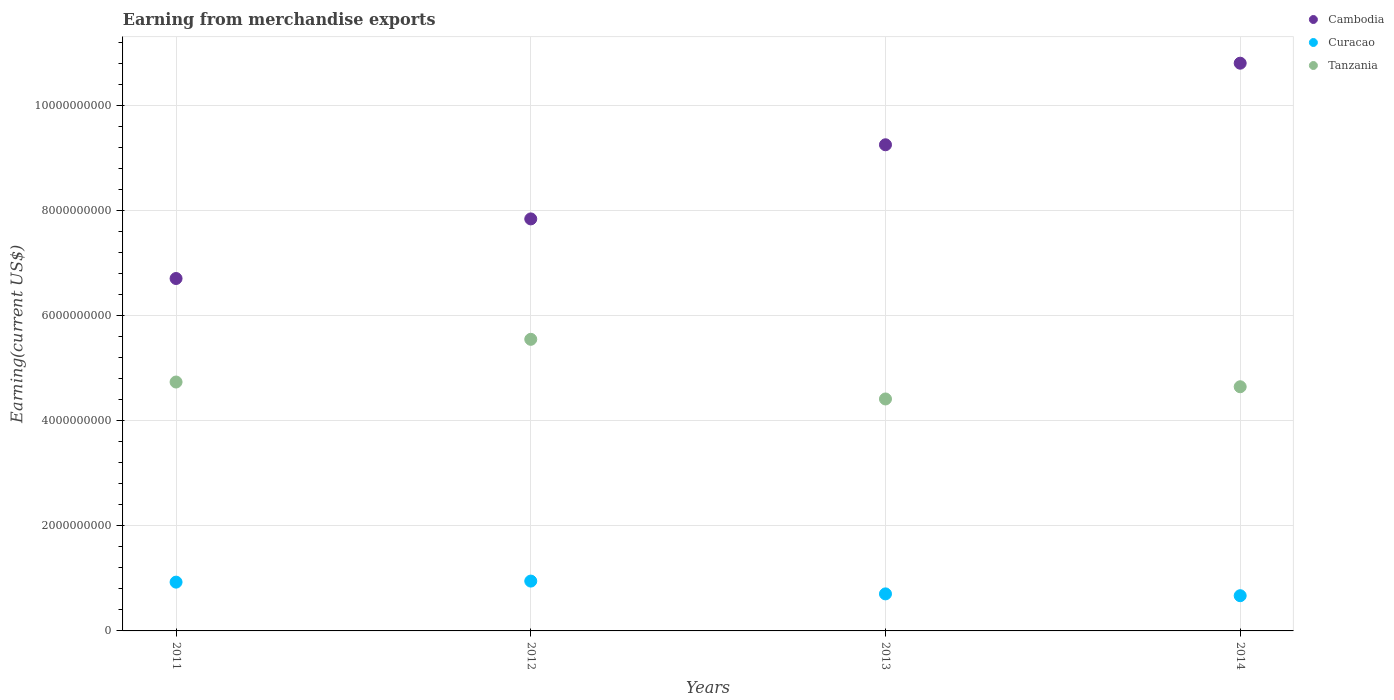What is the amount earned from merchandise exports in Tanzania in 2014?
Make the answer very short. 4.64e+09. Across all years, what is the maximum amount earned from merchandise exports in Cambodia?
Ensure brevity in your answer.  1.08e+1. Across all years, what is the minimum amount earned from merchandise exports in Tanzania?
Keep it short and to the point. 4.41e+09. In which year was the amount earned from merchandise exports in Tanzania maximum?
Your answer should be very brief. 2012. What is the total amount earned from merchandise exports in Cambodia in the graph?
Keep it short and to the point. 3.46e+1. What is the difference between the amount earned from merchandise exports in Cambodia in 2012 and that in 2014?
Your response must be concise. -2.96e+09. What is the difference between the amount earned from merchandise exports in Tanzania in 2011 and the amount earned from merchandise exports in Cambodia in 2014?
Your response must be concise. -6.07e+09. What is the average amount earned from merchandise exports in Cambodia per year?
Keep it short and to the point. 8.65e+09. In the year 2011, what is the difference between the amount earned from merchandise exports in Curacao and amount earned from merchandise exports in Cambodia?
Make the answer very short. -5.78e+09. What is the ratio of the amount earned from merchandise exports in Tanzania in 2012 to that in 2014?
Offer a very short reply. 1.19. Is the amount earned from merchandise exports in Cambodia in 2012 less than that in 2014?
Keep it short and to the point. Yes. Is the difference between the amount earned from merchandise exports in Curacao in 2013 and 2014 greater than the difference between the amount earned from merchandise exports in Cambodia in 2013 and 2014?
Your answer should be compact. Yes. What is the difference between the highest and the second highest amount earned from merchandise exports in Curacao?
Your answer should be very brief. 1.99e+07. What is the difference between the highest and the lowest amount earned from merchandise exports in Tanzania?
Offer a very short reply. 1.13e+09. In how many years, is the amount earned from merchandise exports in Tanzania greater than the average amount earned from merchandise exports in Tanzania taken over all years?
Make the answer very short. 1. Is the sum of the amount earned from merchandise exports in Tanzania in 2011 and 2012 greater than the maximum amount earned from merchandise exports in Curacao across all years?
Make the answer very short. Yes. Is it the case that in every year, the sum of the amount earned from merchandise exports in Tanzania and amount earned from merchandise exports in Curacao  is greater than the amount earned from merchandise exports in Cambodia?
Offer a terse response. No. Does the amount earned from merchandise exports in Tanzania monotonically increase over the years?
Ensure brevity in your answer.  No. Is the amount earned from merchandise exports in Tanzania strictly greater than the amount earned from merchandise exports in Cambodia over the years?
Make the answer very short. No. Is the amount earned from merchandise exports in Tanzania strictly less than the amount earned from merchandise exports in Cambodia over the years?
Your response must be concise. Yes. What is the difference between two consecutive major ticks on the Y-axis?
Your response must be concise. 2.00e+09. Are the values on the major ticks of Y-axis written in scientific E-notation?
Your answer should be very brief. No. Does the graph contain any zero values?
Your response must be concise. No. Does the graph contain grids?
Offer a terse response. Yes. How many legend labels are there?
Ensure brevity in your answer.  3. How are the legend labels stacked?
Keep it short and to the point. Vertical. What is the title of the graph?
Make the answer very short. Earning from merchandise exports. What is the label or title of the Y-axis?
Offer a very short reply. Earning(current US$). What is the Earning(current US$) of Cambodia in 2011?
Make the answer very short. 6.70e+09. What is the Earning(current US$) of Curacao in 2011?
Your answer should be compact. 9.28e+08. What is the Earning(current US$) in Tanzania in 2011?
Your answer should be very brief. 4.73e+09. What is the Earning(current US$) of Cambodia in 2012?
Give a very brief answer. 7.84e+09. What is the Earning(current US$) in Curacao in 2012?
Give a very brief answer. 9.48e+08. What is the Earning(current US$) in Tanzania in 2012?
Provide a succinct answer. 5.55e+09. What is the Earning(current US$) of Cambodia in 2013?
Make the answer very short. 9.25e+09. What is the Earning(current US$) in Curacao in 2013?
Your response must be concise. 7.05e+08. What is the Earning(current US$) in Tanzania in 2013?
Ensure brevity in your answer.  4.41e+09. What is the Earning(current US$) of Cambodia in 2014?
Keep it short and to the point. 1.08e+1. What is the Earning(current US$) of Curacao in 2014?
Your answer should be very brief. 6.70e+08. What is the Earning(current US$) of Tanzania in 2014?
Provide a short and direct response. 4.64e+09. Across all years, what is the maximum Earning(current US$) of Cambodia?
Your answer should be very brief. 1.08e+1. Across all years, what is the maximum Earning(current US$) in Curacao?
Keep it short and to the point. 9.48e+08. Across all years, what is the maximum Earning(current US$) in Tanzania?
Offer a terse response. 5.55e+09. Across all years, what is the minimum Earning(current US$) in Cambodia?
Give a very brief answer. 6.70e+09. Across all years, what is the minimum Earning(current US$) of Curacao?
Ensure brevity in your answer.  6.70e+08. Across all years, what is the minimum Earning(current US$) of Tanzania?
Offer a terse response. 4.41e+09. What is the total Earning(current US$) in Cambodia in the graph?
Offer a terse response. 3.46e+1. What is the total Earning(current US$) in Curacao in the graph?
Provide a succinct answer. 3.25e+09. What is the total Earning(current US$) of Tanzania in the graph?
Offer a terse response. 1.93e+1. What is the difference between the Earning(current US$) in Cambodia in 2011 and that in 2012?
Your response must be concise. -1.13e+09. What is the difference between the Earning(current US$) in Curacao in 2011 and that in 2012?
Provide a succinct answer. -1.99e+07. What is the difference between the Earning(current US$) of Tanzania in 2011 and that in 2012?
Provide a succinct answer. -8.12e+08. What is the difference between the Earning(current US$) in Cambodia in 2011 and that in 2013?
Your answer should be very brief. -2.54e+09. What is the difference between the Earning(current US$) in Curacao in 2011 and that in 2013?
Give a very brief answer. 2.24e+08. What is the difference between the Earning(current US$) in Tanzania in 2011 and that in 2013?
Ensure brevity in your answer.  3.22e+08. What is the difference between the Earning(current US$) in Cambodia in 2011 and that in 2014?
Your answer should be very brief. -4.10e+09. What is the difference between the Earning(current US$) of Curacao in 2011 and that in 2014?
Offer a terse response. 2.58e+08. What is the difference between the Earning(current US$) in Tanzania in 2011 and that in 2014?
Keep it short and to the point. 9.00e+07. What is the difference between the Earning(current US$) in Cambodia in 2012 and that in 2013?
Your answer should be very brief. -1.41e+09. What is the difference between the Earning(current US$) of Curacao in 2012 and that in 2013?
Make the answer very short. 2.44e+08. What is the difference between the Earning(current US$) in Tanzania in 2012 and that in 2013?
Make the answer very short. 1.13e+09. What is the difference between the Earning(current US$) of Cambodia in 2012 and that in 2014?
Offer a very short reply. -2.96e+09. What is the difference between the Earning(current US$) in Curacao in 2012 and that in 2014?
Offer a terse response. 2.78e+08. What is the difference between the Earning(current US$) in Tanzania in 2012 and that in 2014?
Give a very brief answer. 9.02e+08. What is the difference between the Earning(current US$) in Cambodia in 2013 and that in 2014?
Ensure brevity in your answer.  -1.55e+09. What is the difference between the Earning(current US$) of Curacao in 2013 and that in 2014?
Make the answer very short. 3.45e+07. What is the difference between the Earning(current US$) of Tanzania in 2013 and that in 2014?
Make the answer very short. -2.32e+08. What is the difference between the Earning(current US$) of Cambodia in 2011 and the Earning(current US$) of Curacao in 2012?
Your answer should be very brief. 5.76e+09. What is the difference between the Earning(current US$) of Cambodia in 2011 and the Earning(current US$) of Tanzania in 2012?
Provide a short and direct response. 1.16e+09. What is the difference between the Earning(current US$) in Curacao in 2011 and the Earning(current US$) in Tanzania in 2012?
Your answer should be very brief. -4.62e+09. What is the difference between the Earning(current US$) of Cambodia in 2011 and the Earning(current US$) of Curacao in 2013?
Make the answer very short. 6.00e+09. What is the difference between the Earning(current US$) in Cambodia in 2011 and the Earning(current US$) in Tanzania in 2013?
Offer a terse response. 2.29e+09. What is the difference between the Earning(current US$) of Curacao in 2011 and the Earning(current US$) of Tanzania in 2013?
Give a very brief answer. -3.48e+09. What is the difference between the Earning(current US$) in Cambodia in 2011 and the Earning(current US$) in Curacao in 2014?
Offer a very short reply. 6.03e+09. What is the difference between the Earning(current US$) of Cambodia in 2011 and the Earning(current US$) of Tanzania in 2014?
Provide a succinct answer. 2.06e+09. What is the difference between the Earning(current US$) in Curacao in 2011 and the Earning(current US$) in Tanzania in 2014?
Give a very brief answer. -3.72e+09. What is the difference between the Earning(current US$) in Cambodia in 2012 and the Earning(current US$) in Curacao in 2013?
Your response must be concise. 7.13e+09. What is the difference between the Earning(current US$) of Cambodia in 2012 and the Earning(current US$) of Tanzania in 2013?
Provide a short and direct response. 3.43e+09. What is the difference between the Earning(current US$) of Curacao in 2012 and the Earning(current US$) of Tanzania in 2013?
Offer a very short reply. -3.46e+09. What is the difference between the Earning(current US$) of Cambodia in 2012 and the Earning(current US$) of Curacao in 2014?
Your answer should be very brief. 7.17e+09. What is the difference between the Earning(current US$) in Cambodia in 2012 and the Earning(current US$) in Tanzania in 2014?
Your answer should be very brief. 3.19e+09. What is the difference between the Earning(current US$) of Curacao in 2012 and the Earning(current US$) of Tanzania in 2014?
Make the answer very short. -3.70e+09. What is the difference between the Earning(current US$) in Cambodia in 2013 and the Earning(current US$) in Curacao in 2014?
Give a very brief answer. 8.58e+09. What is the difference between the Earning(current US$) of Cambodia in 2013 and the Earning(current US$) of Tanzania in 2014?
Your answer should be compact. 4.60e+09. What is the difference between the Earning(current US$) of Curacao in 2013 and the Earning(current US$) of Tanzania in 2014?
Keep it short and to the point. -3.94e+09. What is the average Earning(current US$) in Cambodia per year?
Keep it short and to the point. 8.65e+09. What is the average Earning(current US$) in Curacao per year?
Your answer should be very brief. 8.13e+08. What is the average Earning(current US$) in Tanzania per year?
Give a very brief answer. 4.83e+09. In the year 2011, what is the difference between the Earning(current US$) in Cambodia and Earning(current US$) in Curacao?
Your answer should be compact. 5.78e+09. In the year 2011, what is the difference between the Earning(current US$) of Cambodia and Earning(current US$) of Tanzania?
Your response must be concise. 1.97e+09. In the year 2011, what is the difference between the Earning(current US$) of Curacao and Earning(current US$) of Tanzania?
Provide a succinct answer. -3.81e+09. In the year 2012, what is the difference between the Earning(current US$) of Cambodia and Earning(current US$) of Curacao?
Provide a short and direct response. 6.89e+09. In the year 2012, what is the difference between the Earning(current US$) of Cambodia and Earning(current US$) of Tanzania?
Ensure brevity in your answer.  2.29e+09. In the year 2012, what is the difference between the Earning(current US$) of Curacao and Earning(current US$) of Tanzania?
Ensure brevity in your answer.  -4.60e+09. In the year 2013, what is the difference between the Earning(current US$) of Cambodia and Earning(current US$) of Curacao?
Make the answer very short. 8.54e+09. In the year 2013, what is the difference between the Earning(current US$) of Cambodia and Earning(current US$) of Tanzania?
Provide a succinct answer. 4.84e+09. In the year 2013, what is the difference between the Earning(current US$) of Curacao and Earning(current US$) of Tanzania?
Your response must be concise. -3.71e+09. In the year 2014, what is the difference between the Earning(current US$) of Cambodia and Earning(current US$) of Curacao?
Your answer should be very brief. 1.01e+1. In the year 2014, what is the difference between the Earning(current US$) in Cambodia and Earning(current US$) in Tanzania?
Your answer should be compact. 6.16e+09. In the year 2014, what is the difference between the Earning(current US$) of Curacao and Earning(current US$) of Tanzania?
Make the answer very short. -3.98e+09. What is the ratio of the Earning(current US$) of Cambodia in 2011 to that in 2012?
Offer a very short reply. 0.86. What is the ratio of the Earning(current US$) in Tanzania in 2011 to that in 2012?
Make the answer very short. 0.85. What is the ratio of the Earning(current US$) of Cambodia in 2011 to that in 2013?
Your answer should be very brief. 0.72. What is the ratio of the Earning(current US$) in Curacao in 2011 to that in 2013?
Make the answer very short. 1.32. What is the ratio of the Earning(current US$) in Tanzania in 2011 to that in 2013?
Provide a succinct answer. 1.07. What is the ratio of the Earning(current US$) in Cambodia in 2011 to that in 2014?
Offer a very short reply. 0.62. What is the ratio of the Earning(current US$) of Curacao in 2011 to that in 2014?
Offer a terse response. 1.39. What is the ratio of the Earning(current US$) in Tanzania in 2011 to that in 2014?
Keep it short and to the point. 1.02. What is the ratio of the Earning(current US$) in Cambodia in 2012 to that in 2013?
Your answer should be very brief. 0.85. What is the ratio of the Earning(current US$) of Curacao in 2012 to that in 2013?
Your answer should be compact. 1.35. What is the ratio of the Earning(current US$) of Tanzania in 2012 to that in 2013?
Offer a very short reply. 1.26. What is the ratio of the Earning(current US$) of Cambodia in 2012 to that in 2014?
Offer a terse response. 0.73. What is the ratio of the Earning(current US$) of Curacao in 2012 to that in 2014?
Make the answer very short. 1.42. What is the ratio of the Earning(current US$) of Tanzania in 2012 to that in 2014?
Provide a short and direct response. 1.19. What is the ratio of the Earning(current US$) in Cambodia in 2013 to that in 2014?
Offer a terse response. 0.86. What is the ratio of the Earning(current US$) in Curacao in 2013 to that in 2014?
Your answer should be compact. 1.05. What is the ratio of the Earning(current US$) in Tanzania in 2013 to that in 2014?
Provide a succinct answer. 0.95. What is the difference between the highest and the second highest Earning(current US$) in Cambodia?
Your answer should be very brief. 1.55e+09. What is the difference between the highest and the second highest Earning(current US$) of Curacao?
Ensure brevity in your answer.  1.99e+07. What is the difference between the highest and the second highest Earning(current US$) of Tanzania?
Provide a succinct answer. 8.12e+08. What is the difference between the highest and the lowest Earning(current US$) in Cambodia?
Ensure brevity in your answer.  4.10e+09. What is the difference between the highest and the lowest Earning(current US$) of Curacao?
Provide a short and direct response. 2.78e+08. What is the difference between the highest and the lowest Earning(current US$) of Tanzania?
Ensure brevity in your answer.  1.13e+09. 